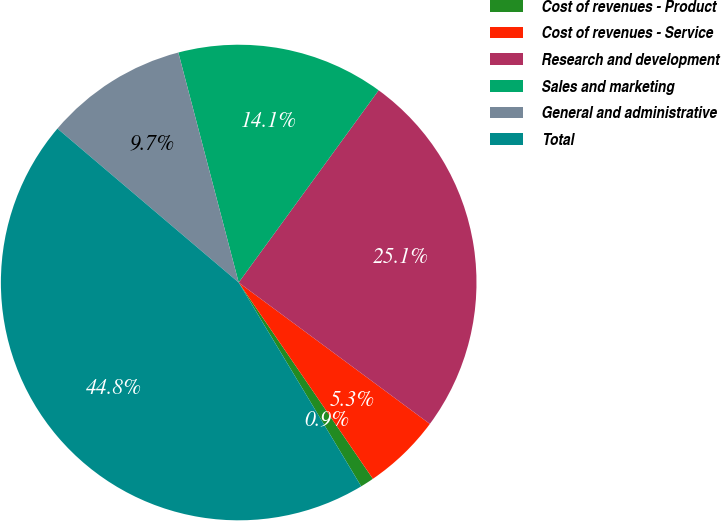<chart> <loc_0><loc_0><loc_500><loc_500><pie_chart><fcel>Cost of revenues - Product<fcel>Cost of revenues - Service<fcel>Research and development<fcel>Sales and marketing<fcel>General and administrative<fcel>Total<nl><fcel>0.93%<fcel>5.32%<fcel>25.12%<fcel>14.1%<fcel>9.71%<fcel>44.82%<nl></chart> 